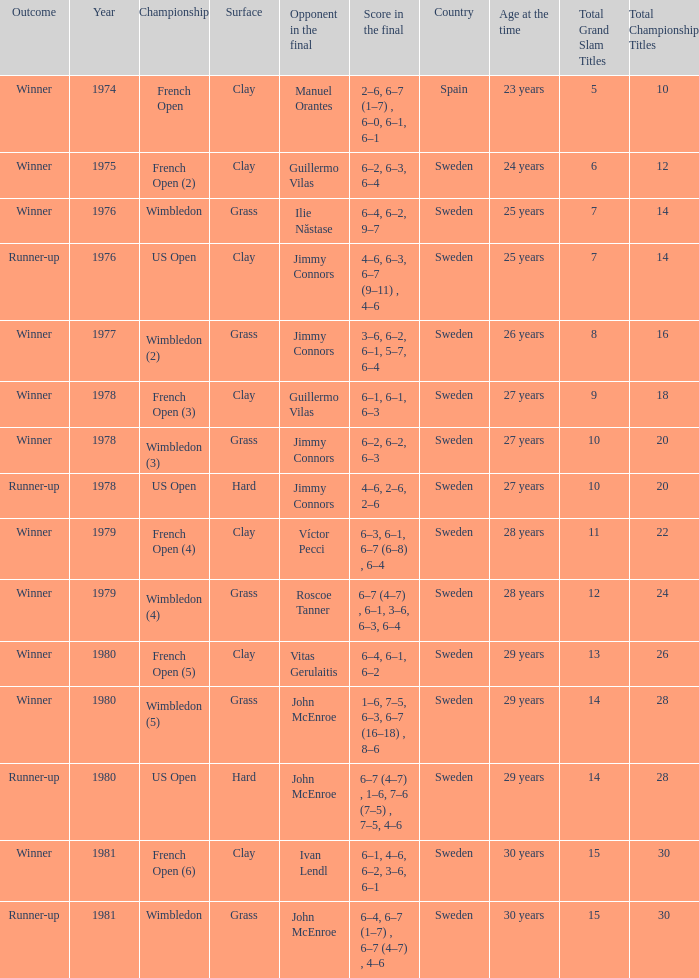What is every surface with a score in the final of 6–4, 6–7 (1–7) , 6–7 (4–7) , 4–6? Grass. 